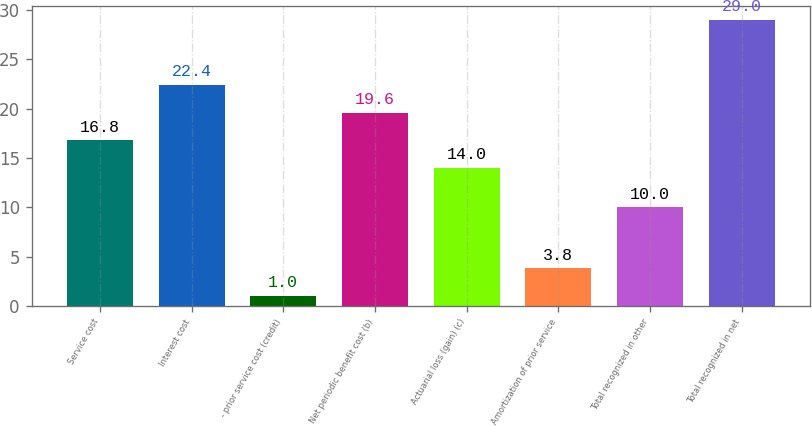<chart> <loc_0><loc_0><loc_500><loc_500><bar_chart><fcel>Service cost<fcel>Interest cost<fcel>- prior service cost (credit)<fcel>Net periodic benefit cost (b)<fcel>Actuarial loss (gain) (c)<fcel>Amortization of prior service<fcel>Total recognized in other<fcel>Total recognized in net<nl><fcel>16.8<fcel>22.4<fcel>1<fcel>19.6<fcel>14<fcel>3.8<fcel>10<fcel>29<nl></chart> 